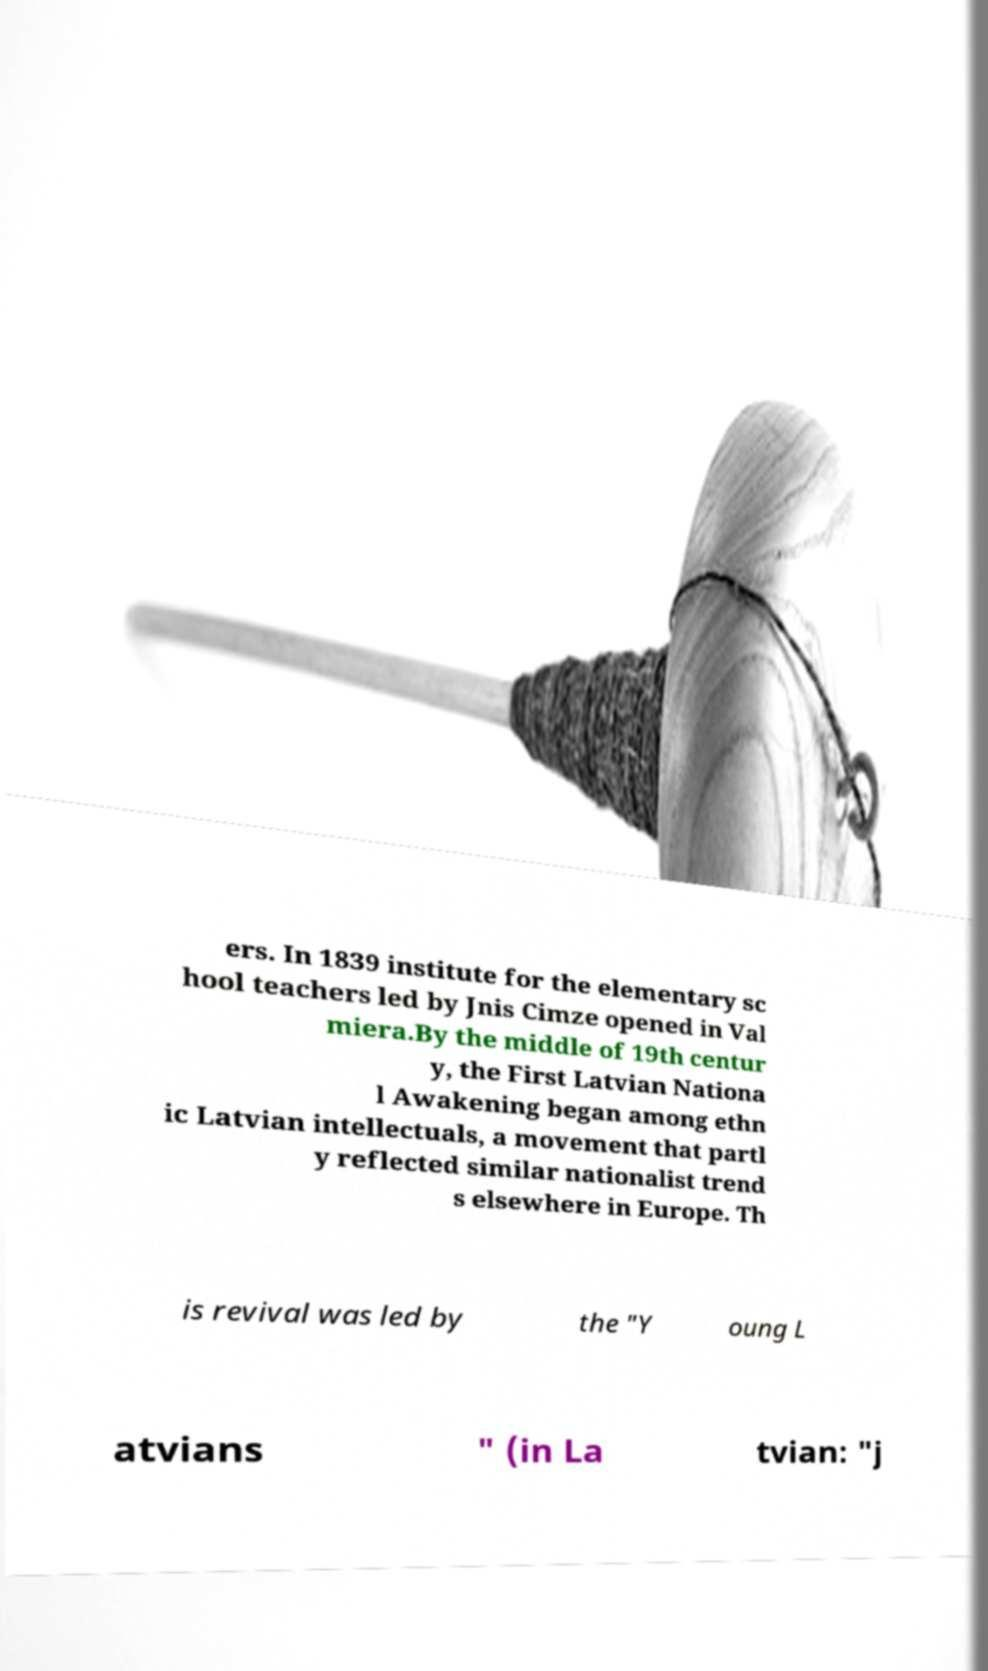Please identify and transcribe the text found in this image. ers. In 1839 institute for the elementary sc hool teachers led by Jnis Cimze opened in Val miera.By the middle of 19th centur y, the First Latvian Nationa l Awakening began among ethn ic Latvian intellectuals, a movement that partl y reflected similar nationalist trend s elsewhere in Europe. Th is revival was led by the "Y oung L atvians " (in La tvian: "j 